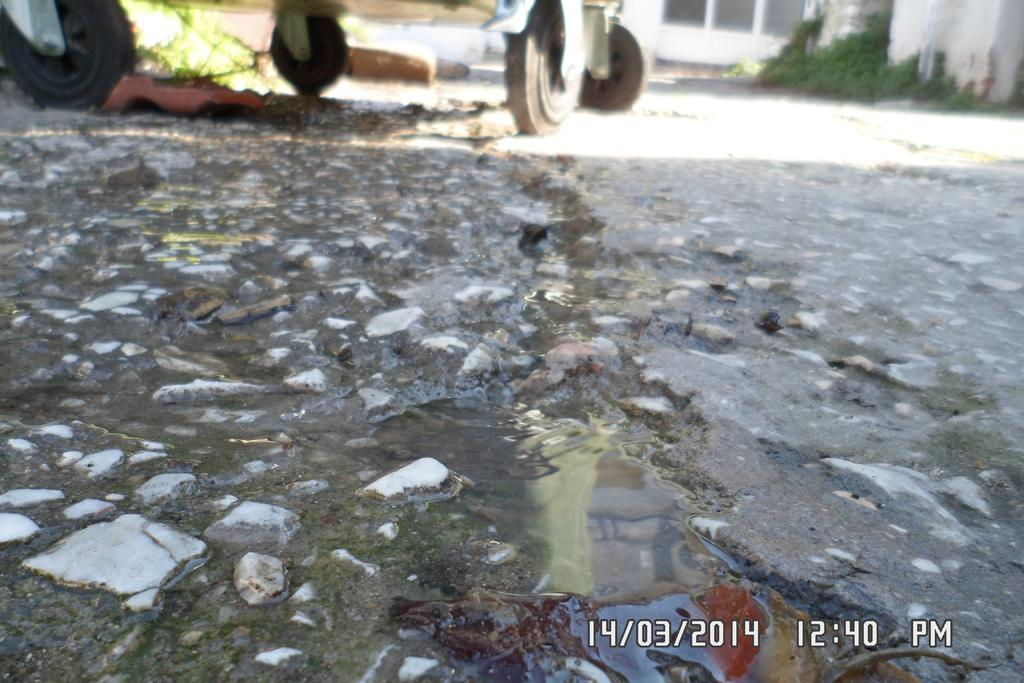What is the primary surface visible in the image? There is a floor in the image. What is on the floor in the image? There is water on the floor. What object can be seen in the background of the image? There is a wheel tray in the background of the image. Where can the time and date be found in the image? The time and date are present at the bottom of the image. How many chickens are wearing skirts in the image? There are no chickens or skirts present in the image. What decision is being made by the people in the image? There are no people or decisions being made in the image. 